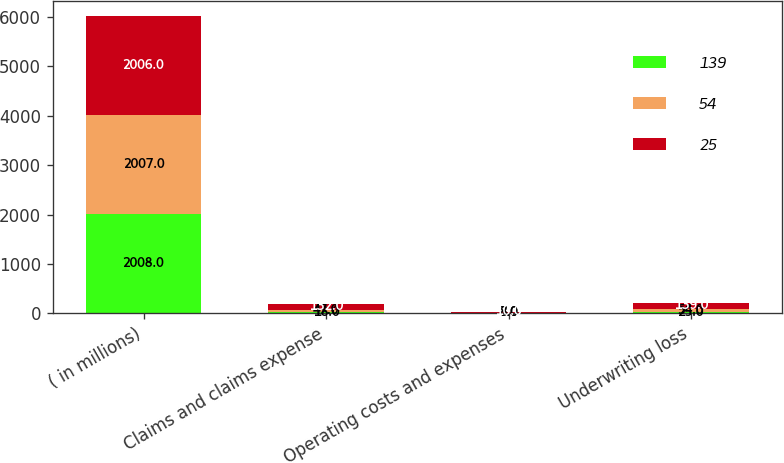<chart> <loc_0><loc_0><loc_500><loc_500><stacked_bar_chart><ecel><fcel>( in millions)<fcel>Claims and claims expense<fcel>Operating costs and expenses<fcel>Underwriting loss<nl><fcel>139<fcel>2008<fcel>18<fcel>7<fcel>25<nl><fcel>54<fcel>2007<fcel>47<fcel>8<fcel>54<nl><fcel>25<fcel>2006<fcel>132<fcel>10<fcel>139<nl></chart> 